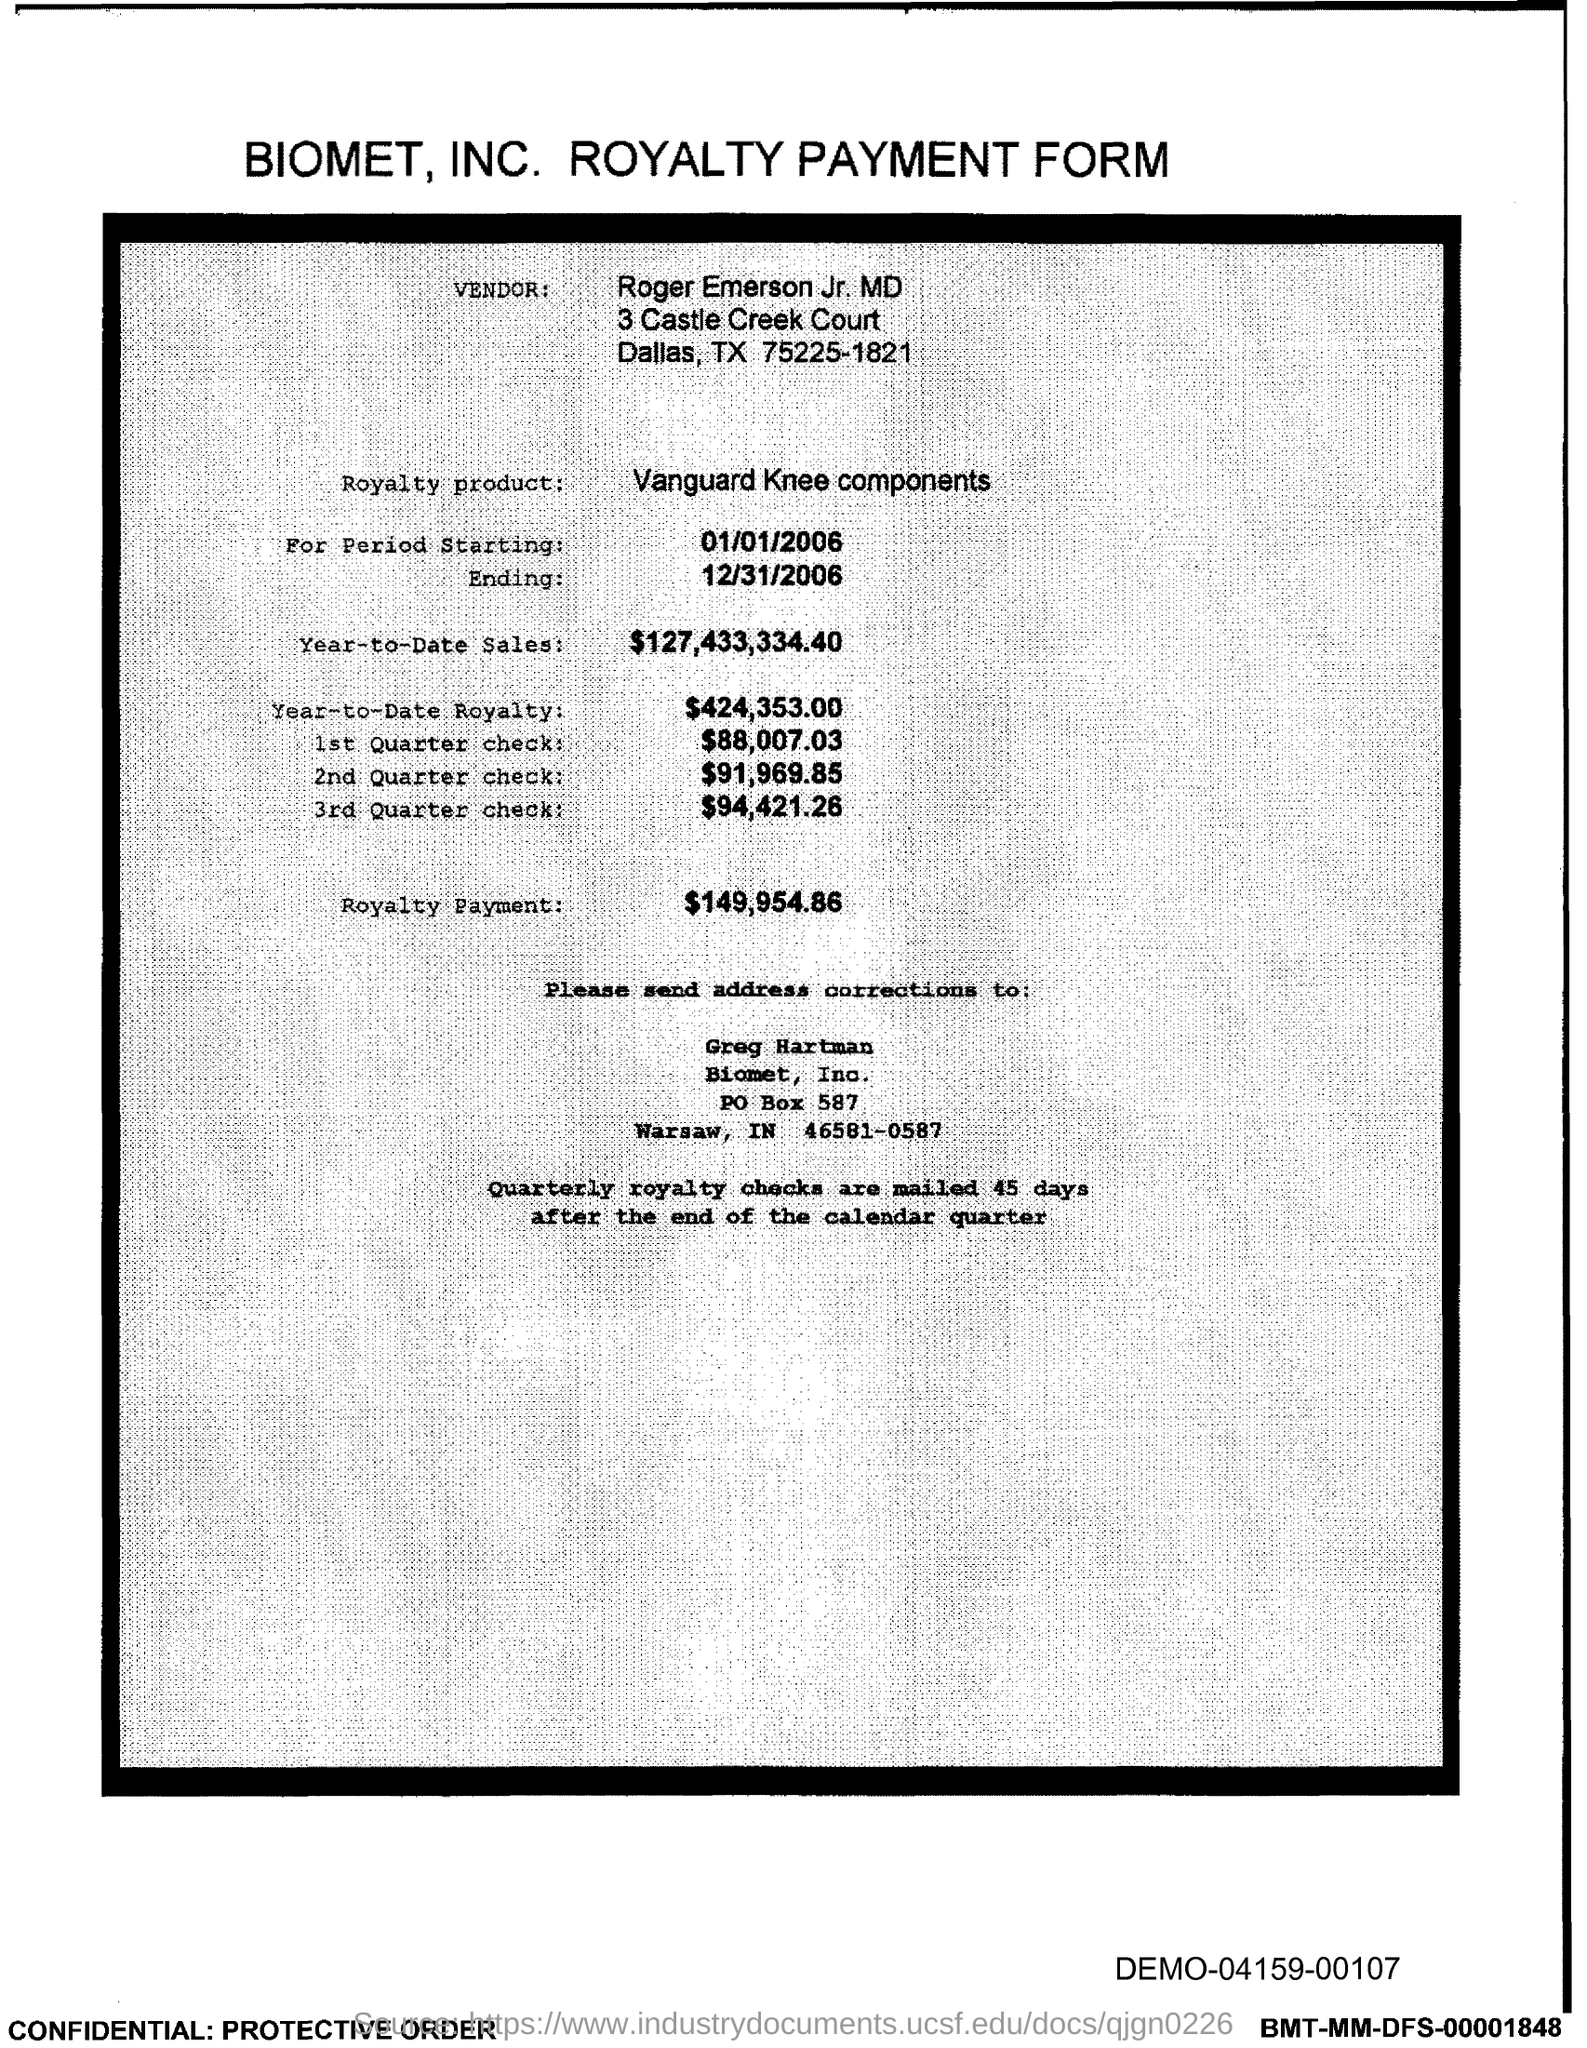Outline some significant characteristics in this image. It has been reported that Roger Emerson Jr., MD, is the vendor in question. The amount of the first quarter check is $88,007.03. The Royalty product mentioned is the Vanguard Knee components, which is a type of medical device developed by Royalty Pharma and marketed by Vanguard Medical Technologies. The royalty payment is $149,954.86. 